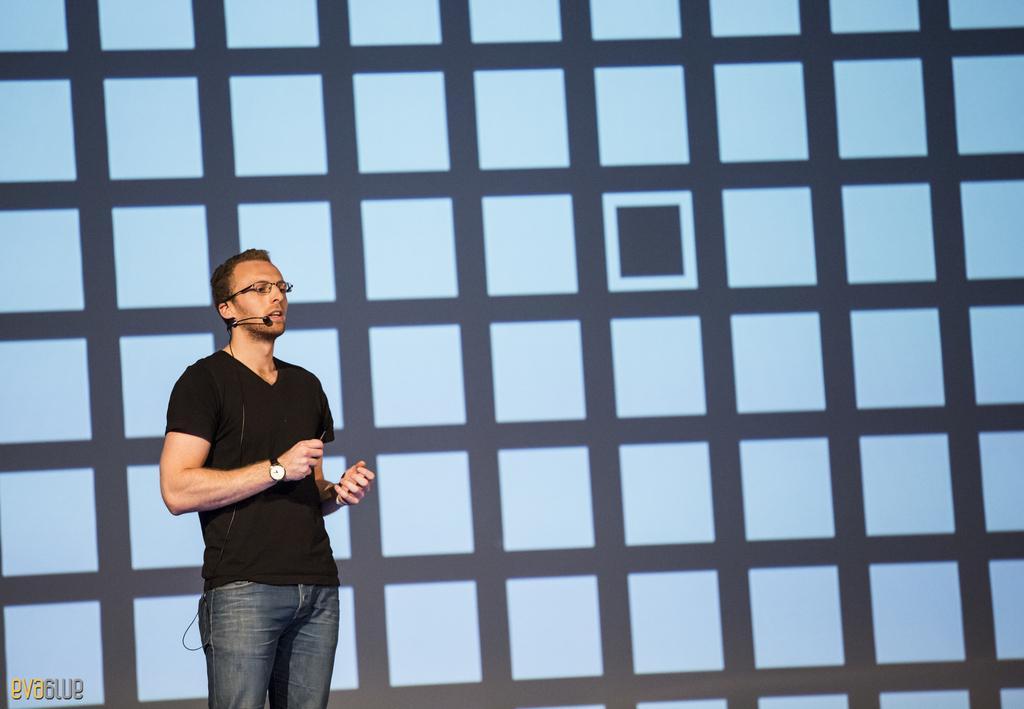How would you summarize this image in a sentence or two? In this image we can see person standing on the ground. In the background there is wall. 